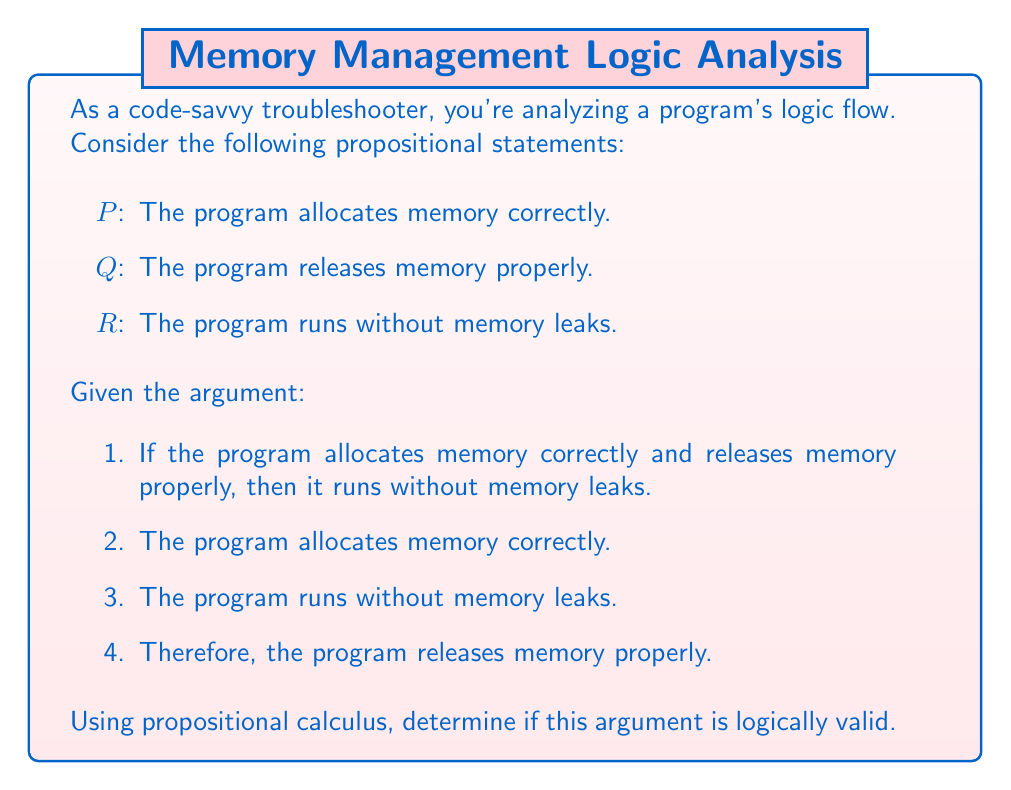Can you solve this math problem? Let's analyze this argument using propositional calculus:

1. Translate the premises and conclusion into symbolic form:
   Premise 1: $(P \land Q) \rightarrow R$
   Premise 2: $P$
   Premise 3: $R$
   Conclusion: $Q$

2. The argument structure is:
   $$(P \land Q) \rightarrow R$$
   $$P$$
   $$R$$
   $$\therefore Q$$

3. To check validity, we need to determine if it's possible for all premises to be true while the conclusion is false.

4. Let's consider a truth table for this scenario:

   $$\begin{array}{|c|c|c|c|c|}
   \hline
   P & Q & R & (P \land Q) \rightarrow R & \text{Valid?} \\
   \hline
   T & T & T & T & \text{Yes} \\
   T & T & F & F & \text{No (violates premise 3)} \\
   T & F & T & T & \text{Yes} \\
   T & F & F & T & \text{No (violates premise 3)} \\
   F & T & T & T & \text{No (violates premise 2)} \\
   F & T & F & T & \text{No (violates premises 2 and 3)} \\
   F & F & T & T & \text{No (violates premise 2)} \\
   F & F & F & T & \text{No (violates premises 2 and 3)} \\
   \hline
   \end{array}$$

5. From the truth table, we can see that there's a scenario where all premises are true (P = T, Q = F, R = T), but the conclusion (Q) is false.

6. This demonstrates that the argument is not logically valid. It's possible for the program to allocate memory correctly and run without memory leaks, even if it doesn't release memory properly (there might be other mechanisms preventing leaks).
Answer: Not valid 